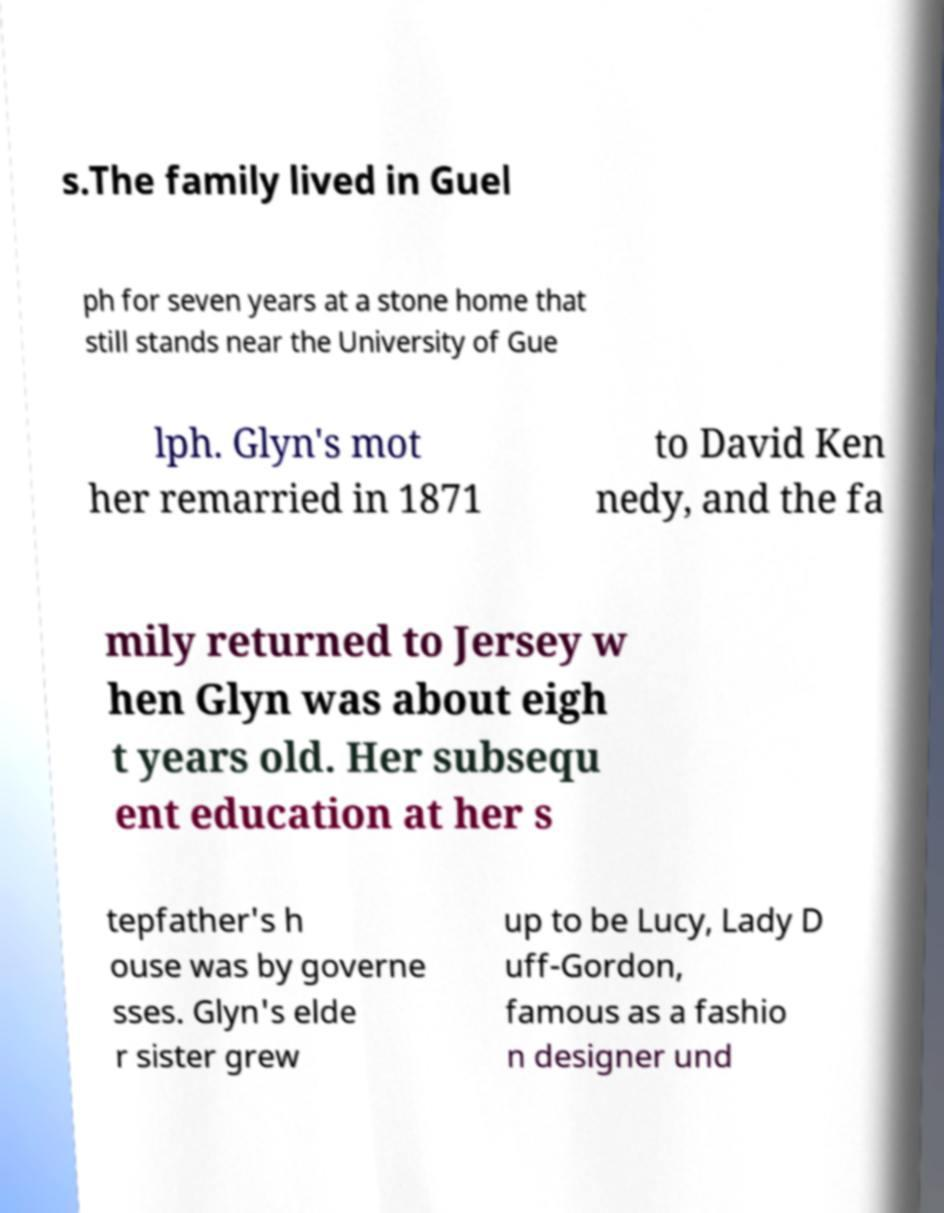For documentation purposes, I need the text within this image transcribed. Could you provide that? s.The family lived in Guel ph for seven years at a stone home that still stands near the University of Gue lph. Glyn's mot her remarried in 1871 to David Ken nedy, and the fa mily returned to Jersey w hen Glyn was about eigh t years old. Her subsequ ent education at her s tepfather's h ouse was by governe sses. Glyn's elde r sister grew up to be Lucy, Lady D uff-Gordon, famous as a fashio n designer und 